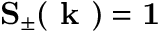<formula> <loc_0><loc_0><loc_500><loc_500>S _ { \pm } ( k ) = 1</formula> 